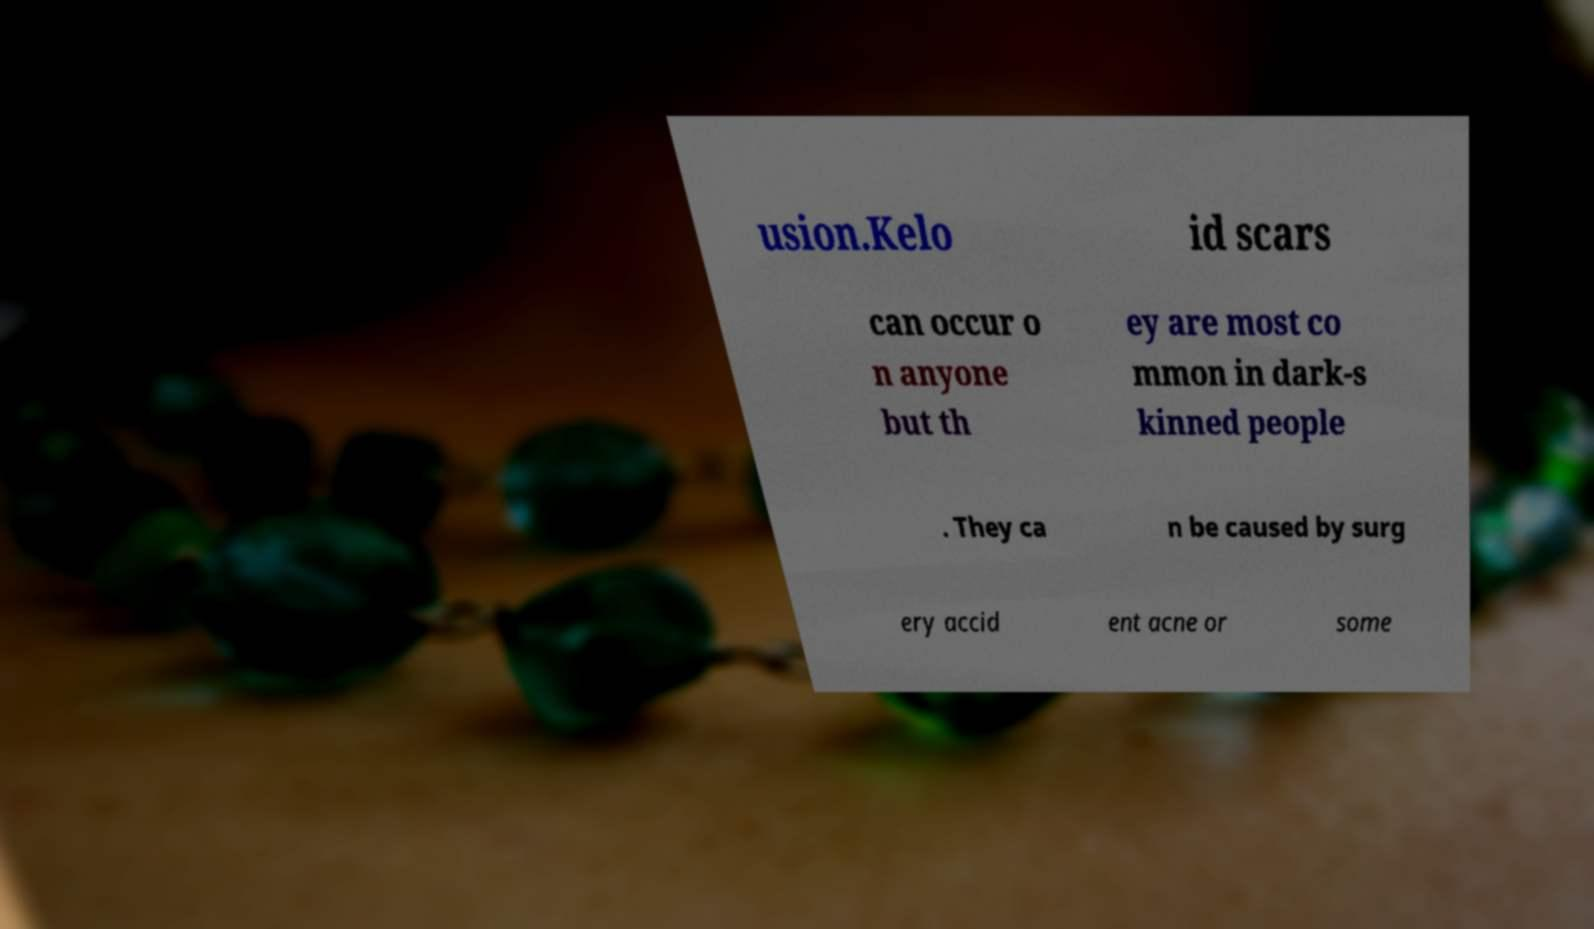Can you accurately transcribe the text from the provided image for me? usion.Kelo id scars can occur o n anyone but th ey are most co mmon in dark-s kinned people . They ca n be caused by surg ery accid ent acne or some 